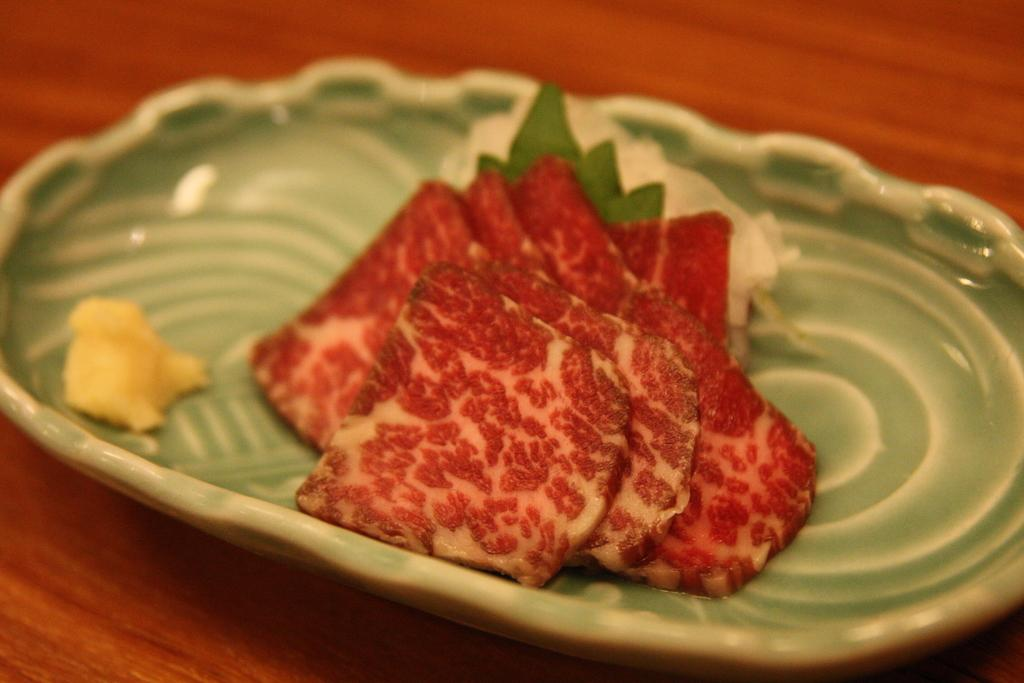Where can you find the dolls selling their handmade copies at the market in the image? There is no market, dolls, or copies present in the image. 